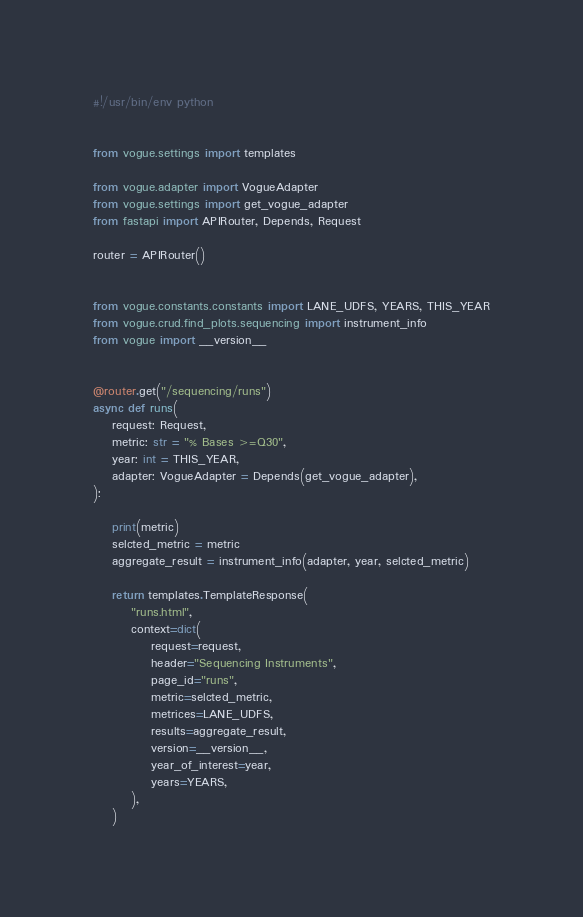Convert code to text. <code><loc_0><loc_0><loc_500><loc_500><_Python_>#!/usr/bin/env python


from vogue.settings import templates

from vogue.adapter import VogueAdapter
from vogue.settings import get_vogue_adapter
from fastapi import APIRouter, Depends, Request

router = APIRouter()


from vogue.constants.constants import LANE_UDFS, YEARS, THIS_YEAR
from vogue.crud.find_plots.sequencing import instrument_info
from vogue import __version__


@router.get("/sequencing/runs")
async def runs(
    request: Request,
    metric: str = "% Bases >=Q30",
    year: int = THIS_YEAR,
    adapter: VogueAdapter = Depends(get_vogue_adapter),
):

    print(metric)
    selcted_metric = metric
    aggregate_result = instrument_info(adapter, year, selcted_metric)

    return templates.TemplateResponse(
        "runs.html",
        context=dict(
            request=request,
            header="Sequencing Instruments",
            page_id="runs",
            metric=selcted_metric,
            metrices=LANE_UDFS,
            results=aggregate_result,
            version=__version__,
            year_of_interest=year,
            years=YEARS,
        ),
    )
</code> 